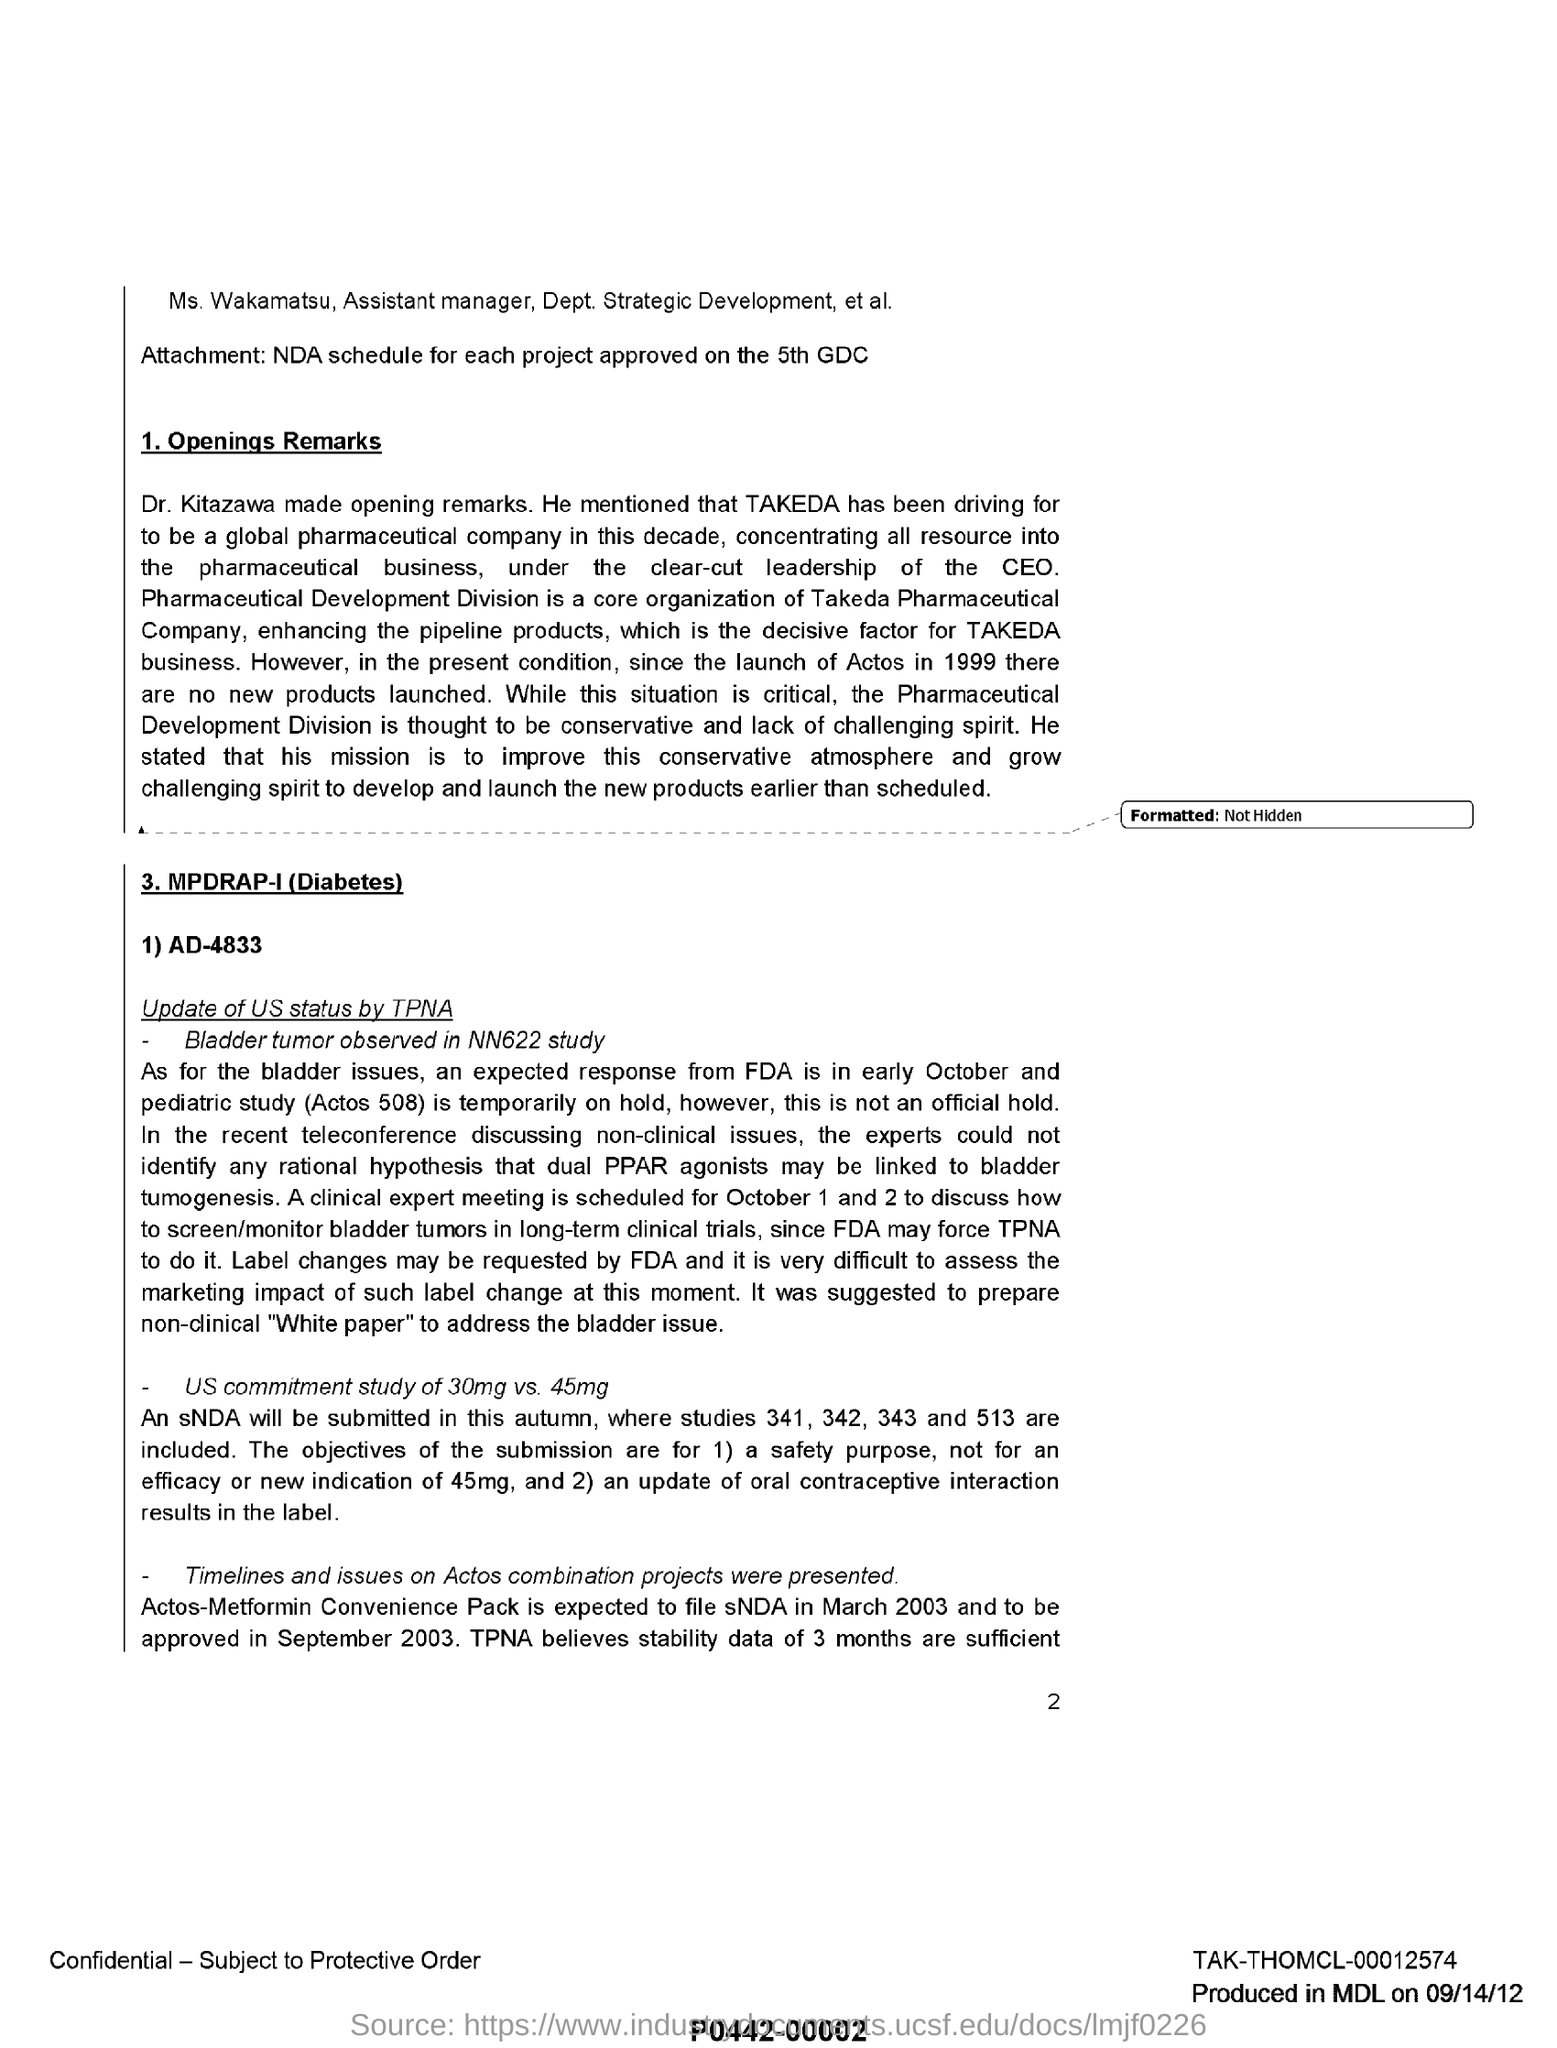Which is the core organization of Takeda pharmaceutical Company?
Your answer should be compact. Pharmaceutical development Division. Who made the opening remarks ?
Your answer should be compact. Dr. Kitazawa. When is the clinical expert meeting scheduled?
Your response must be concise. October 1 and 2. Why was it suggested to prepare non-clinical "White paper"?
Make the answer very short. To address the bladder issue. What is Ms Wakamatsu's role in Dept. Strategic Development?
Give a very brief answer. Assistant manager. 